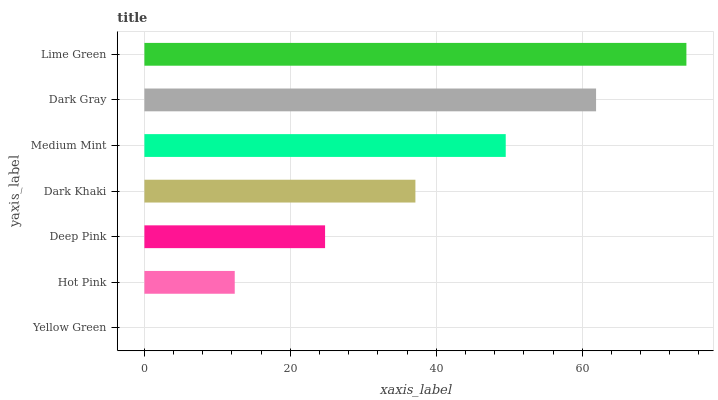Is Yellow Green the minimum?
Answer yes or no. Yes. Is Lime Green the maximum?
Answer yes or no. Yes. Is Hot Pink the minimum?
Answer yes or no. No. Is Hot Pink the maximum?
Answer yes or no. No. Is Hot Pink greater than Yellow Green?
Answer yes or no. Yes. Is Yellow Green less than Hot Pink?
Answer yes or no. Yes. Is Yellow Green greater than Hot Pink?
Answer yes or no. No. Is Hot Pink less than Yellow Green?
Answer yes or no. No. Is Dark Khaki the high median?
Answer yes or no. Yes. Is Dark Khaki the low median?
Answer yes or no. Yes. Is Dark Gray the high median?
Answer yes or no. No. Is Dark Gray the low median?
Answer yes or no. No. 